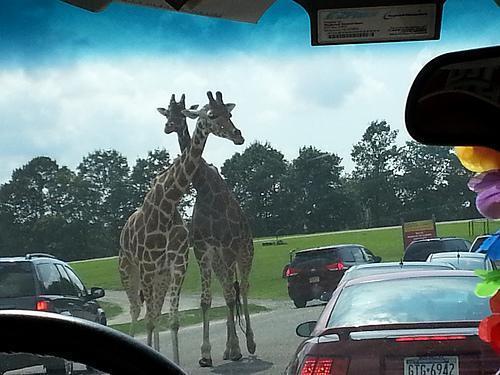How many giraffes are in this photo?
Give a very brief answer. 2. 